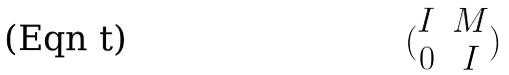<formula> <loc_0><loc_0><loc_500><loc_500>( \begin{matrix} I & M \\ 0 & I \end{matrix} )</formula> 